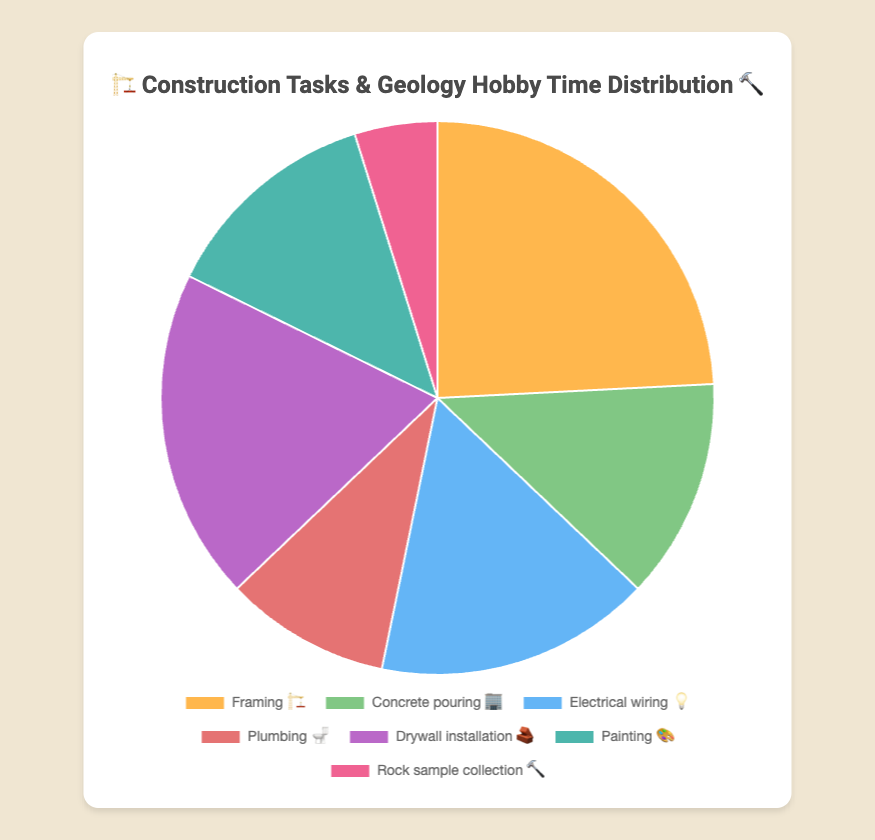what is the total time spent on "Framing 🏗️" and "Drywall installation 🧱"? Add the hours for "Framing 🏗️" (15 hours) and "Drywall installation 🧱" (12 hours): 15 + 12 = 27 hours
Answer: 27 hours which task had the least time spent on it? Check the task with the smallest hours value, which is "Rock sample collection 🔨" with 3 hours
Answer: Rock sample collection 🔨 how much more time is spent on "Electrical wiring 💡" compared to "Plumbing 🚽"? Subtract the hours for "Plumbing 🚽" (6 hours) from those for "Electrical wiring 💡" (10 hours): 10 - 6 = 4 hours
Answer: 4 hours what task takes up exactly 8 hours? Check tasks with 8 hours, which are "Concrete pouring 🏢" and "Painting 🎨"
Answer: Concrete pouring 🏢 and Painting 🎨 how many tasks take up more than 10 hours? Count tasks with hours greater than 10: "Framing 🏗️" with 15 hours and "Drywall installation 🧱" with 12 hours
Answer: 2 tasks what is the total time spent on all tasks combined? Sum all task hours: 15 + 8 + 10 + 6 + 12 + 8 + 3 = 62 hours
Answer: 62 hours which task has more time spent on it, "Framing 🏗️" or "Painting 🎨"? Compare hours for "Framing 🏗️" (15 hours) and "Painting 🎨" (8 hours): 15 > 8
Answer: Framing 🏗️ what is the average time spent on "Electrical wiring 💡", "Plumbing 🚽", and "Painting 🎨"? Add hours for "Electrical wiring 💡" (10), "Plumbing 🚽" (6), and "Painting 🎨" (8), then divide by 3: (10 + 6 + 8) / 3 = 8 hours
Answer: 8 hours which construction task had exactly the same time spent on it as the geology hobby task "Rock sample collection 🔨"? Check if any task has the same hours as "Rock sample collection 🔨" (3), none match
Answer: None what percentage of the total time is spent on "Framing 🏗️"? Divide hours for "Framing 🏗️" (15) by total hours (62), then multiply by 100: (15 / 62) * 100 ≈ 24.19%
Answer: 24.19% 